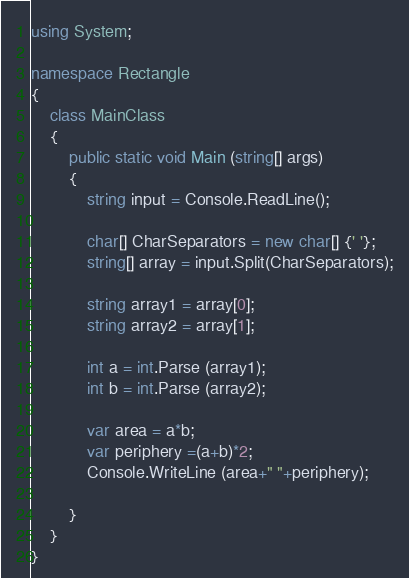Convert code to text. <code><loc_0><loc_0><loc_500><loc_500><_C#_>using System;

namespace Rectangle
{
	class MainClass
	{
		public static void Main (string[] args)
		{
			string input = Console.ReadLine();
		
			char[] CharSeparators = new char[] {' '};
			string[] array = input.Split(CharSeparators);

			string array1 = array[0];
			string array2 = array[1];

			int a = int.Parse (array1);
			int b = int.Parse (array2);

			var area = a*b;
			var periphery =(a+b)*2;
			Console.WriteLine (area+" "+periphery);

		}
	}
}</code> 